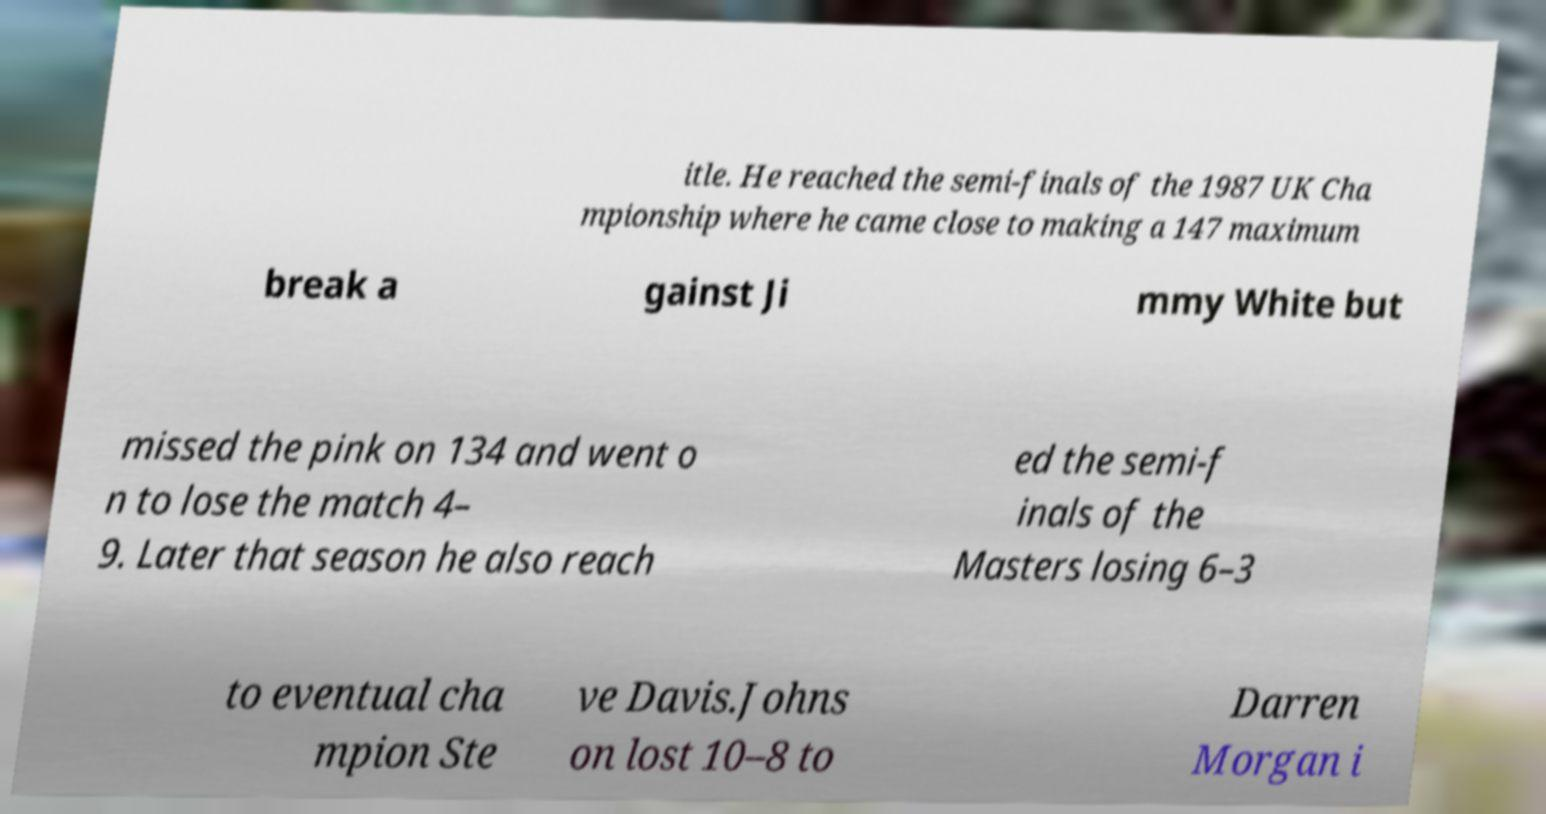I need the written content from this picture converted into text. Can you do that? itle. He reached the semi-finals of the 1987 UK Cha mpionship where he came close to making a 147 maximum break a gainst Ji mmy White but missed the pink on 134 and went o n to lose the match 4– 9. Later that season he also reach ed the semi-f inals of the Masters losing 6–3 to eventual cha mpion Ste ve Davis.Johns on lost 10–8 to Darren Morgan i 